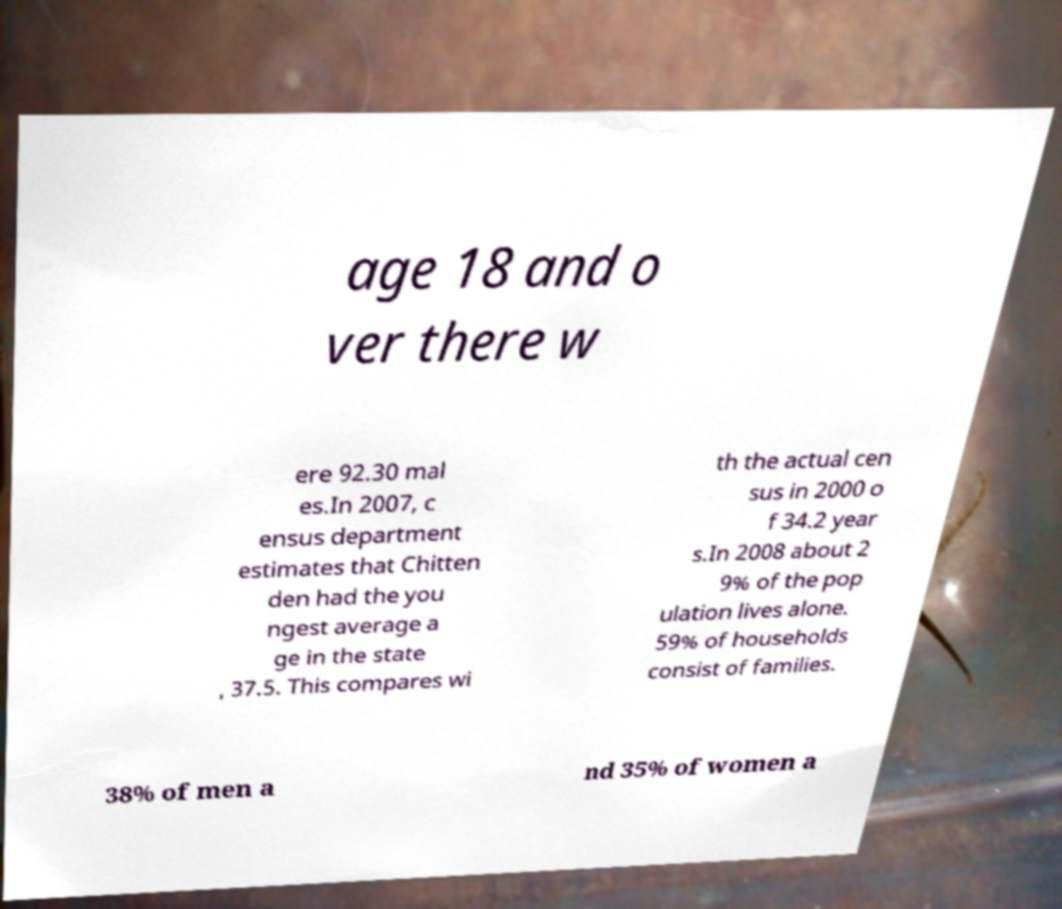I need the written content from this picture converted into text. Can you do that? age 18 and o ver there w ere 92.30 mal es.In 2007, c ensus department estimates that Chitten den had the you ngest average a ge in the state , 37.5. This compares wi th the actual cen sus in 2000 o f 34.2 year s.In 2008 about 2 9% of the pop ulation lives alone. 59% of households consist of families. 38% of men a nd 35% of women a 